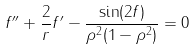Convert formula to latex. <formula><loc_0><loc_0><loc_500><loc_500>f ^ { \prime \prime } + \frac { 2 } { r } f ^ { \prime } - \frac { \sin ( 2 f ) } { \rho ^ { 2 } ( 1 - \rho ^ { 2 } ) } = 0</formula> 